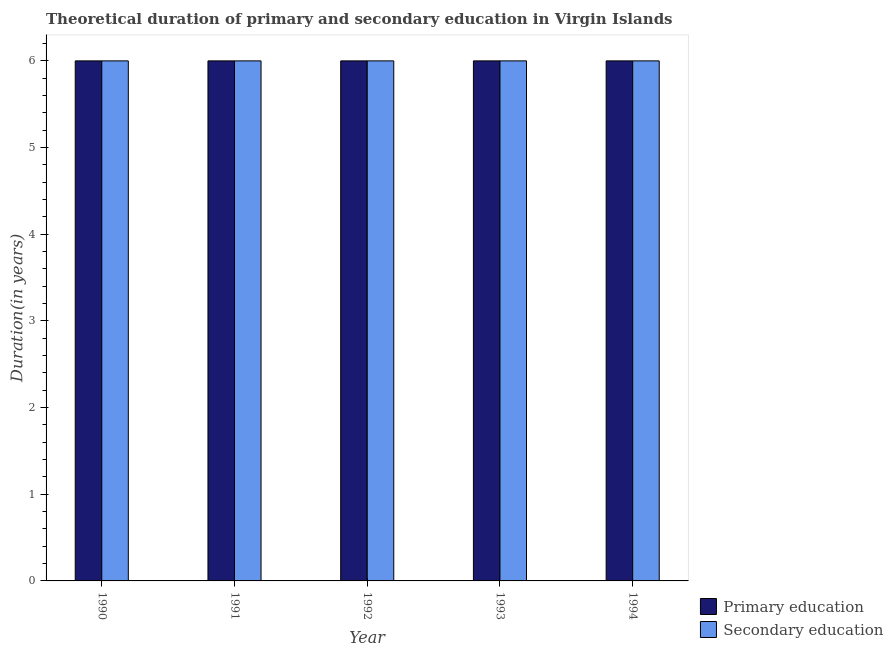How many groups of bars are there?
Provide a succinct answer. 5. Are the number of bars on each tick of the X-axis equal?
Provide a succinct answer. Yes. In how many cases, is the number of bars for a given year not equal to the number of legend labels?
Provide a succinct answer. 0. Across all years, what is the minimum duration of secondary education?
Keep it short and to the point. 6. What is the total duration of primary education in the graph?
Your response must be concise. 30. What is the difference between the duration of primary education in 1991 and that in 1992?
Keep it short and to the point. 0. What is the average duration of secondary education per year?
Your answer should be very brief. 6. In the year 1992, what is the difference between the duration of secondary education and duration of primary education?
Give a very brief answer. 0. In how many years, is the duration of primary education greater than 4.4 years?
Offer a very short reply. 5. What is the ratio of the duration of secondary education in 1991 to that in 1993?
Your answer should be compact. 1. Is the duration of secondary education in 1990 less than that in 1991?
Provide a succinct answer. No. What is the difference between the highest and the lowest duration of primary education?
Your response must be concise. 0. In how many years, is the duration of primary education greater than the average duration of primary education taken over all years?
Your answer should be compact. 0. What does the 1st bar from the left in 1992 represents?
Give a very brief answer. Primary education. What does the 2nd bar from the right in 1993 represents?
Your answer should be very brief. Primary education. How many bars are there?
Offer a terse response. 10. How many years are there in the graph?
Keep it short and to the point. 5. Are the values on the major ticks of Y-axis written in scientific E-notation?
Give a very brief answer. No. Does the graph contain any zero values?
Your response must be concise. No. Does the graph contain grids?
Offer a very short reply. No. How many legend labels are there?
Offer a very short reply. 2. How are the legend labels stacked?
Your answer should be very brief. Vertical. What is the title of the graph?
Ensure brevity in your answer.  Theoretical duration of primary and secondary education in Virgin Islands. Does "Male" appear as one of the legend labels in the graph?
Your answer should be very brief. No. What is the label or title of the X-axis?
Provide a succinct answer. Year. What is the label or title of the Y-axis?
Your answer should be compact. Duration(in years). What is the Duration(in years) of Secondary education in 1990?
Your answer should be very brief. 6. What is the Duration(in years) of Secondary education in 1991?
Offer a terse response. 6. What is the Duration(in years) of Secondary education in 1992?
Keep it short and to the point. 6. What is the Duration(in years) in Primary education in 1993?
Offer a terse response. 6. What is the Duration(in years) of Secondary education in 1994?
Offer a terse response. 6. Across all years, what is the maximum Duration(in years) of Primary education?
Make the answer very short. 6. Across all years, what is the maximum Duration(in years) of Secondary education?
Your answer should be very brief. 6. Across all years, what is the minimum Duration(in years) in Primary education?
Provide a succinct answer. 6. What is the total Duration(in years) of Secondary education in the graph?
Provide a succinct answer. 30. What is the difference between the Duration(in years) of Primary education in 1990 and that in 1991?
Ensure brevity in your answer.  0. What is the difference between the Duration(in years) in Primary education in 1990 and that in 1992?
Your response must be concise. 0. What is the difference between the Duration(in years) in Primary education in 1990 and that in 1994?
Offer a very short reply. 0. What is the difference between the Duration(in years) of Primary education in 1991 and that in 1992?
Ensure brevity in your answer.  0. What is the difference between the Duration(in years) in Secondary education in 1991 and that in 1992?
Offer a very short reply. 0. What is the difference between the Duration(in years) of Secondary education in 1991 and that in 1994?
Offer a very short reply. 0. What is the difference between the Duration(in years) in Primary education in 1992 and that in 1994?
Offer a terse response. 0. What is the difference between the Duration(in years) in Secondary education in 1992 and that in 1994?
Give a very brief answer. 0. What is the difference between the Duration(in years) in Primary education in 1993 and that in 1994?
Your answer should be very brief. 0. What is the difference between the Duration(in years) of Secondary education in 1993 and that in 1994?
Your response must be concise. 0. What is the difference between the Duration(in years) in Primary education in 1990 and the Duration(in years) in Secondary education in 1992?
Provide a succinct answer. 0. What is the difference between the Duration(in years) of Primary education in 1991 and the Duration(in years) of Secondary education in 1993?
Provide a succinct answer. 0. What is the difference between the Duration(in years) in Primary education in 1992 and the Duration(in years) in Secondary education in 1993?
Ensure brevity in your answer.  0. In the year 1990, what is the difference between the Duration(in years) of Primary education and Duration(in years) of Secondary education?
Offer a terse response. 0. In the year 1992, what is the difference between the Duration(in years) in Primary education and Duration(in years) in Secondary education?
Provide a succinct answer. 0. In the year 1993, what is the difference between the Duration(in years) of Primary education and Duration(in years) of Secondary education?
Keep it short and to the point. 0. What is the ratio of the Duration(in years) in Primary education in 1990 to that in 1991?
Keep it short and to the point. 1. What is the ratio of the Duration(in years) of Secondary education in 1990 to that in 1992?
Your answer should be compact. 1. What is the ratio of the Duration(in years) of Secondary education in 1990 to that in 1993?
Offer a terse response. 1. What is the ratio of the Duration(in years) of Primary education in 1990 to that in 1994?
Offer a very short reply. 1. What is the ratio of the Duration(in years) of Primary education in 1991 to that in 1992?
Provide a succinct answer. 1. What is the ratio of the Duration(in years) in Primary education in 1991 to that in 1993?
Ensure brevity in your answer.  1. What is the ratio of the Duration(in years) of Secondary education in 1991 to that in 1993?
Provide a short and direct response. 1. What is the ratio of the Duration(in years) in Primary education in 1991 to that in 1994?
Your answer should be very brief. 1. What is the ratio of the Duration(in years) of Secondary education in 1991 to that in 1994?
Offer a terse response. 1. What is the ratio of the Duration(in years) in Primary education in 1992 to that in 1993?
Your answer should be compact. 1. What is the difference between the highest and the second highest Duration(in years) of Primary education?
Give a very brief answer. 0. What is the difference between the highest and the lowest Duration(in years) of Secondary education?
Give a very brief answer. 0. 